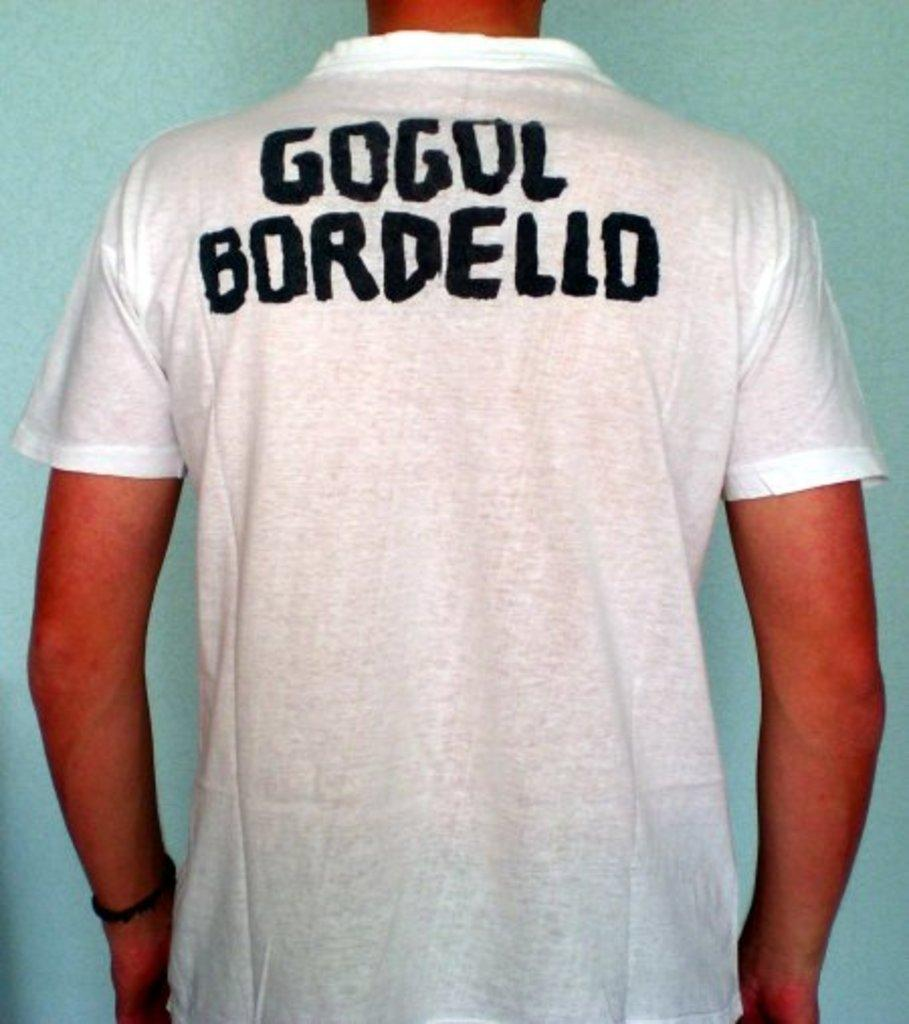<image>
Create a compact narrative representing the image presented. a man wearing a shirt on his back that says Gogul Bordello on it 